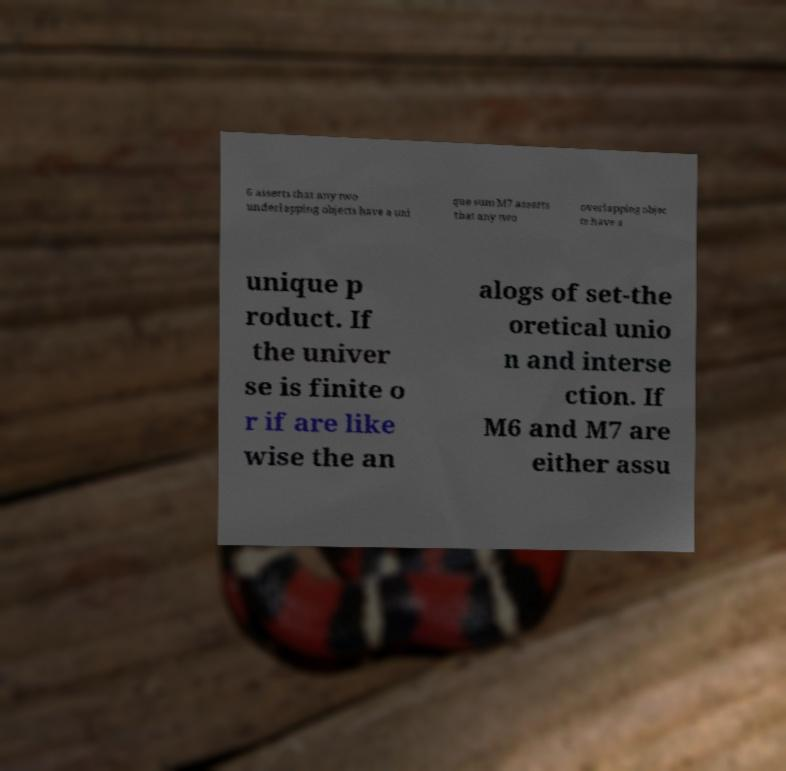What messages or text are displayed in this image? I need them in a readable, typed format. 6 asserts that any two underlapping objects have a uni que sum M7 asserts that any two overlapping objec ts have a unique p roduct. If the univer se is finite o r if are like wise the an alogs of set-the oretical unio n and interse ction. If M6 and M7 are either assu 